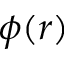<formula> <loc_0><loc_0><loc_500><loc_500>\phi ( r )</formula> 